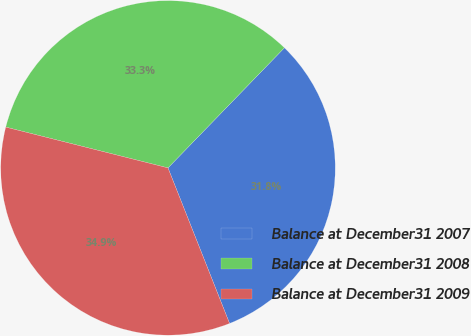Convert chart to OTSL. <chart><loc_0><loc_0><loc_500><loc_500><pie_chart><fcel>Balance at December31 2007<fcel>Balance at December31 2008<fcel>Balance at December31 2009<nl><fcel>31.75%<fcel>33.33%<fcel>34.92%<nl></chart> 